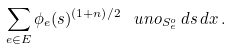Convert formula to latex. <formula><loc_0><loc_0><loc_500><loc_500>\sum _ { e \in E } \phi _ { e } ( s ) ^ { ( 1 + n ) / 2 } \, \ u n o _ { S _ { e } ^ { o } } \, d s \, d x \, .</formula> 